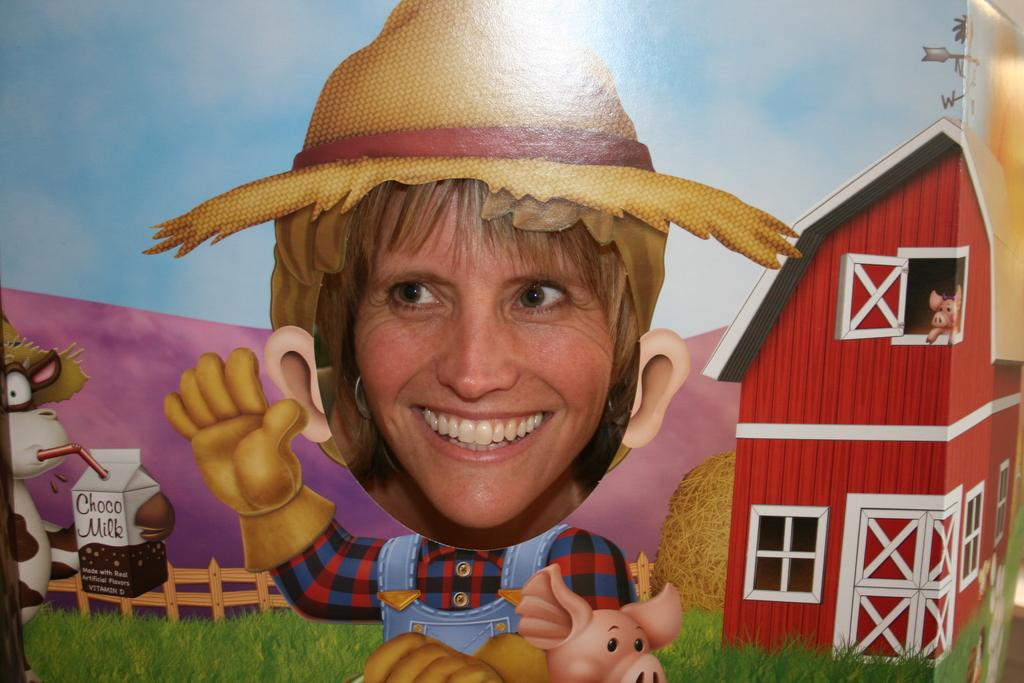Who is present in the image? There is a woman in the image. What is the woman's expression? The woman is smiling. What type of picture can be seen in the image? There is an animated picture in the image. What type of structure is visible in the image? There is a house in the image. What type of vegetation is present in the image? There is grass in the image. What type of barrier is present in the image? There is a fence in the image. What type of object is present in the image? There is a box in the image. What type of drawings are present in the image? There are cartoons in the image. What type of pollution can be seen in the image? There is no pollution present in the image. What type of coastline is visible in the image? There is no coastline present in the image. 